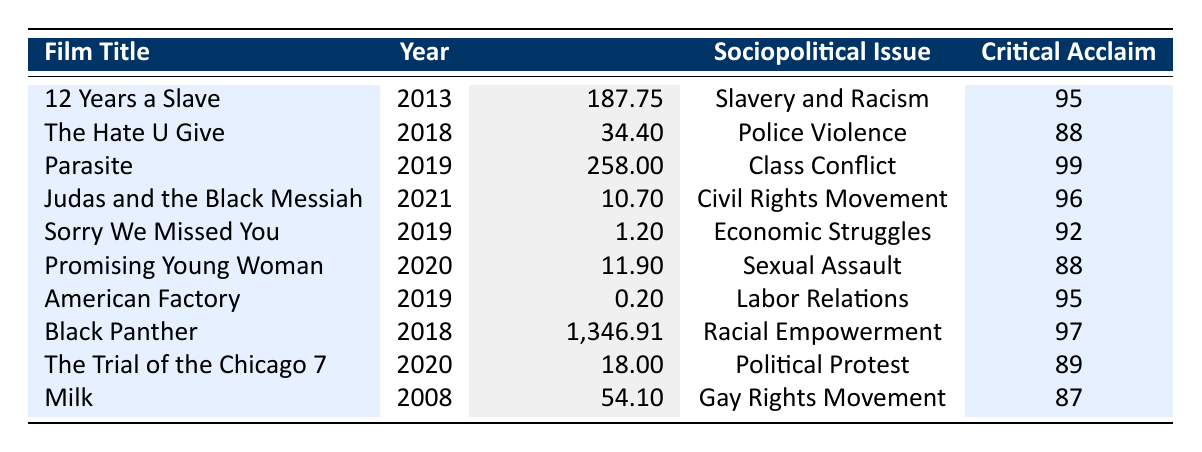What is the highest box office performance among the films in the table? The table lists various films along with their box office earnings. By comparing the box office values, it can be noted that "Black Panther" has the highest box office at $1,346.91 million.
Answer: 1,346.91 million Which film directed by Bong Joon-ho addresses class conflict? The table indicates that "Parasite," directed by Bong Joon-ho, specifically tackles the sociopolitical issue of class conflict.
Answer: Parasite What was the total box office collection of films released in 2019? To find the total, we need to add the box office collections of all films released in 2019: "Parasite" (258 million) + "Sorry We Missed You" (1.2 million) + "American Factory" (0.2 million) = 259.4 million.
Answer: 259.4 million Did "The Hate U Give" receive a higher critical acclaim score than "Promising Young Woman"? "The Hate U Give" has a critical acclaim score of 88, and "Promising Young Woman" also has a score of 88; therefore, they received the same score.
Answer: No Which sociopolitical issue had the lowest box office performance as per the films in the table? Comparing the box office figures, "American Factory" addressing globalization and labor relations recorded the lowest box office at $0.20 million, which is lower than all others listed.
Answer: Globalization and Labor Relations What is the average box office revenue for the films focusing on racial issues? The films with racial issues in the table are "12 Years a Slave" (187.75 million), "The Hate U Give" (34.4 million), "Black Panther" (1,346.91 million), and "Judas and the Black Messiah" (10.7 million). Adding these together gives 1,579.96 million. There are four films, so the average is 1,579.96 million divided by 4, which equals approximately 394.99 million.
Answer: 394.99 million Which film received the highest critical acclaim and what issue does it address? The highest critical acclaim score is 99, which belongs to "Parasite." It addresses the sociopolitical issue of class conflict.
Answer: Parasite, Class Conflict How many films in the table address issues related to gender dynamics? The only film listed that addresses issues related to gender dynamics is "Promising Young Woman." Thus, there is one film.
Answer: 1 What is the box office difference between "12 Years a Slave" and "Judas and the Black Messiah"? "12 Years a Slave" earned 187.75 million, while "Judas and the Black Messiah" earned 10.7 million. The difference is 187.75 million - 10.7 million = 177.05 million.
Answer: 177.05 million Which films released in 2020 had a box office revenue greater than $10 million? The films released in 2020 are "Promising Young Woman" (11.9 million) and "The Trial of the Chicago 7" (18 million). Only "The Trial of the Chicago 7" has a revenue above $10 million.
Answer: The Trial of the Chicago 7 Is there a film in the table that represents multiple sociopolitical issues? The table does not list any film that addresses multiple sociopolitical issues, as each film is associated with a single specific issue.
Answer: No 